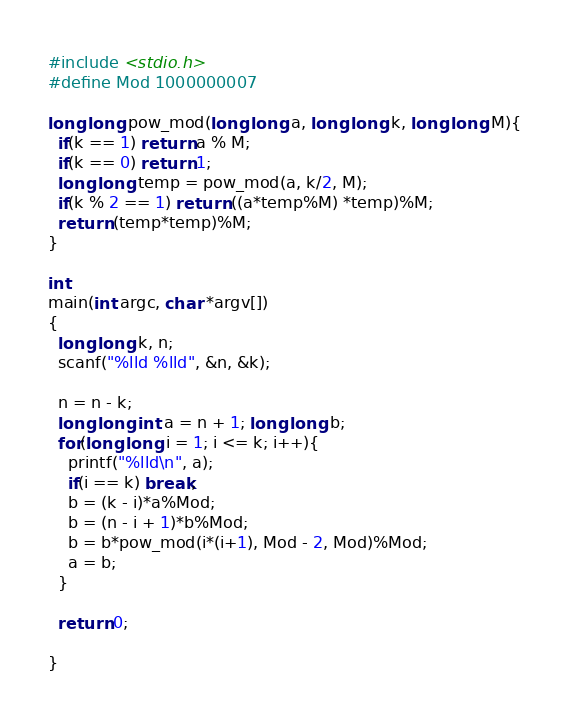<code> <loc_0><loc_0><loc_500><loc_500><_C_>#include <stdio.h>
#define Mod 1000000007

long long pow_mod(long long a, long long k, long long M){
  if(k == 1) return a % M;
  if(k == 0) return 1;
  long long temp = pow_mod(a, k/2, M);
  if(k % 2 == 1) return ((a*temp%M) *temp)%M;
  return (temp*temp)%M;
}

int
main(int argc, char *argv[])
{
  long long k, n;
  scanf("%lld %lld", &n, &k);

  n = n - k;
  long long int a = n + 1; long long b;
  for(long long i = 1; i <= k; i++){
    printf("%lld\n", a);
    if(i == k) break;
    b = (k - i)*a%Mod;
    b = (n - i + 1)*b%Mod;
    b = b*pow_mod(i*(i+1), Mod - 2, Mod)%Mod;
    a = b;
  }

  return 0;

}
</code> 